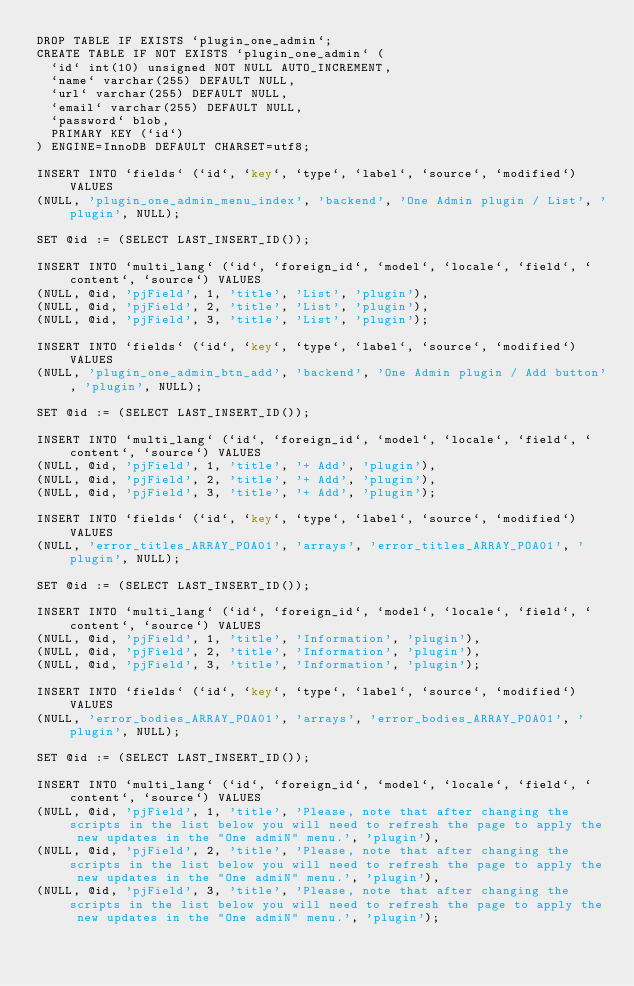Convert code to text. <code><loc_0><loc_0><loc_500><loc_500><_SQL_>DROP TABLE IF EXISTS `plugin_one_admin`;
CREATE TABLE IF NOT EXISTS `plugin_one_admin` (
  `id` int(10) unsigned NOT NULL AUTO_INCREMENT,
  `name` varchar(255) DEFAULT NULL,
  `url` varchar(255) DEFAULT NULL,
  `email` varchar(255) DEFAULT NULL,
  `password` blob,
  PRIMARY KEY (`id`)
) ENGINE=InnoDB DEFAULT CHARSET=utf8;

INSERT INTO `fields` (`id`, `key`, `type`, `label`, `source`, `modified`) VALUES
(NULL, 'plugin_one_admin_menu_index', 'backend', 'One Admin plugin / List', 'plugin', NULL);

SET @id := (SELECT LAST_INSERT_ID());

INSERT INTO `multi_lang` (`id`, `foreign_id`, `model`, `locale`, `field`, `content`, `source`) VALUES
(NULL, @id, 'pjField', 1, 'title', 'List', 'plugin'),
(NULL, @id, 'pjField', 2, 'title', 'List', 'plugin'),
(NULL, @id, 'pjField', 3, 'title', 'List', 'plugin');

INSERT INTO `fields` (`id`, `key`, `type`, `label`, `source`, `modified`) VALUES
(NULL, 'plugin_one_admin_btn_add', 'backend', 'One Admin plugin / Add button', 'plugin', NULL);

SET @id := (SELECT LAST_INSERT_ID());

INSERT INTO `multi_lang` (`id`, `foreign_id`, `model`, `locale`, `field`, `content`, `source`) VALUES
(NULL, @id, 'pjField', 1, 'title', '+ Add', 'plugin'),
(NULL, @id, 'pjField', 2, 'title', '+ Add', 'plugin'),
(NULL, @id, 'pjField', 3, 'title', '+ Add', 'plugin');

INSERT INTO `fields` (`id`, `key`, `type`, `label`, `source`, `modified`) VALUES
(NULL, 'error_titles_ARRAY_POA01', 'arrays', 'error_titles_ARRAY_POA01', 'plugin', NULL);

SET @id := (SELECT LAST_INSERT_ID());

INSERT INTO `multi_lang` (`id`, `foreign_id`, `model`, `locale`, `field`, `content`, `source`) VALUES
(NULL, @id, 'pjField', 1, 'title', 'Information', 'plugin'),
(NULL, @id, 'pjField', 2, 'title', 'Information', 'plugin'),
(NULL, @id, 'pjField', 3, 'title', 'Information', 'plugin');

INSERT INTO `fields` (`id`, `key`, `type`, `label`, `source`, `modified`) VALUES
(NULL, 'error_bodies_ARRAY_POA01', 'arrays', 'error_bodies_ARRAY_POA01', 'plugin', NULL);

SET @id := (SELECT LAST_INSERT_ID());

INSERT INTO `multi_lang` (`id`, `foreign_id`, `model`, `locale`, `field`, `content`, `source`) VALUES
(NULL, @id, 'pjField', 1, 'title', 'Please, note that after changing the scripts in the list below you will need to refresh the page to apply the new updates in the "One admiN" menu.', 'plugin'),
(NULL, @id, 'pjField', 2, 'title', 'Please, note that after changing the scripts in the list below you will need to refresh the page to apply the new updates in the "One admiN" menu.', 'plugin'),
(NULL, @id, 'pjField', 3, 'title', 'Please, note that after changing the scripts in the list below you will need to refresh the page to apply the new updates in the "One admiN" menu.', 'plugin');</code> 